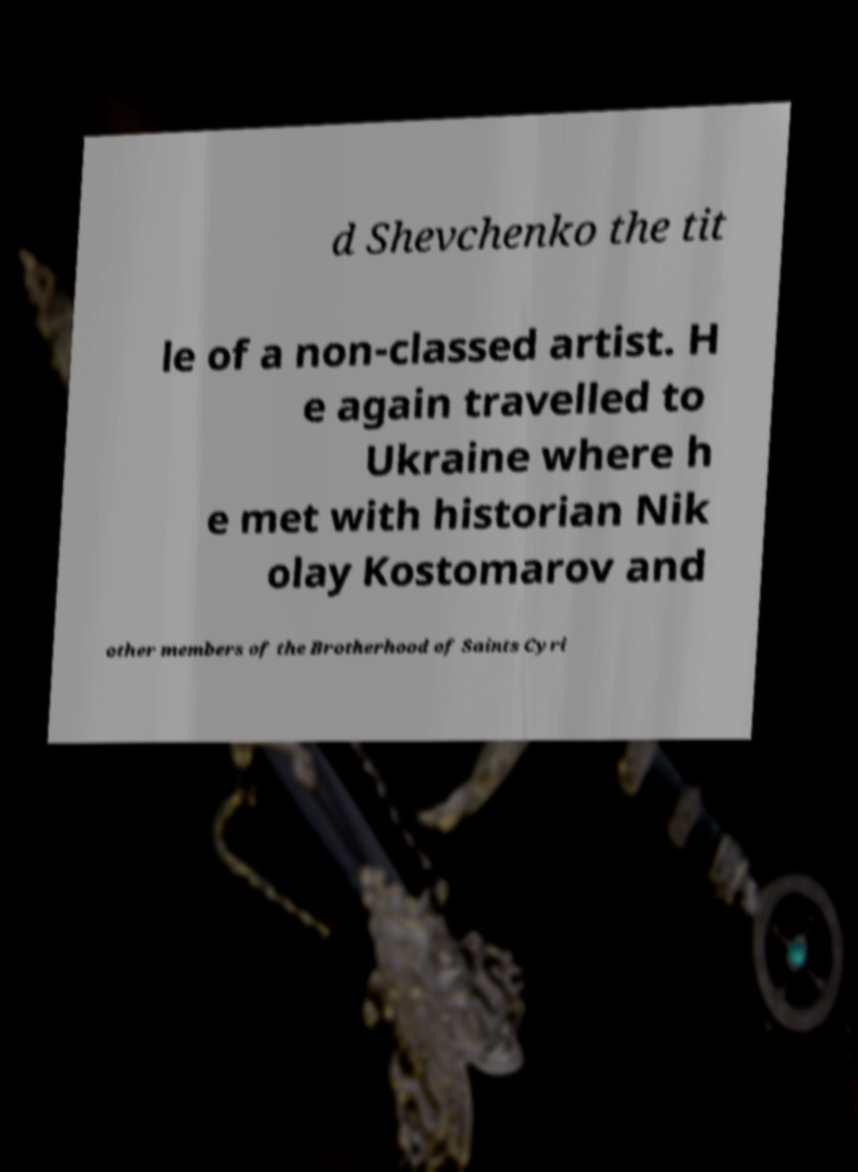Please read and relay the text visible in this image. What does it say? d Shevchenko the tit le of a non-classed artist. H e again travelled to Ukraine where h e met with historian Nik olay Kostomarov and other members of the Brotherhood of Saints Cyri 